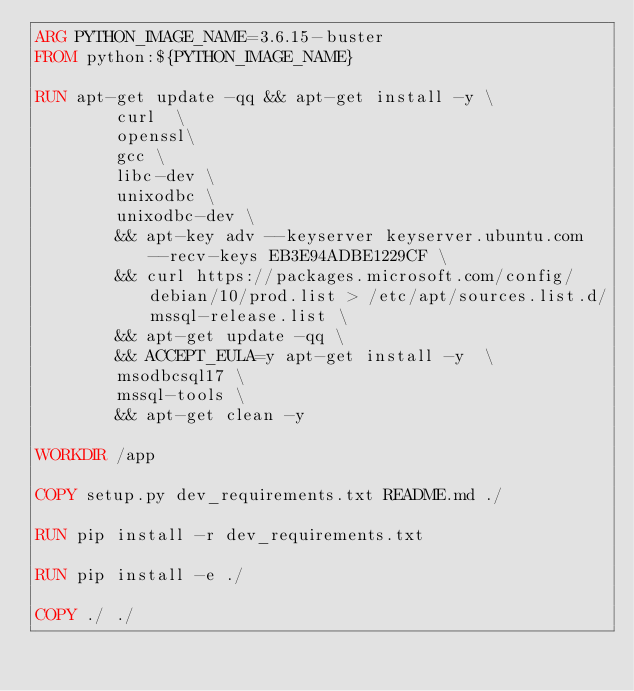<code> <loc_0><loc_0><loc_500><loc_500><_Dockerfile_>ARG PYTHON_IMAGE_NAME=3.6.15-buster
FROM python:${PYTHON_IMAGE_NAME}

RUN apt-get update -qq && apt-get install -y \
        curl  \
        openssl\
        gcc \
        libc-dev \
        unixodbc \
        unixodbc-dev \
        && apt-key adv --keyserver keyserver.ubuntu.com --recv-keys EB3E94ADBE1229CF \
        && curl https://packages.microsoft.com/config/debian/10/prod.list > /etc/apt/sources.list.d/mssql-release.list \
        && apt-get update -qq \
        && ACCEPT_EULA=y apt-get install -y  \
        msodbcsql17 \
        mssql-tools \
        && apt-get clean -y

WORKDIR /app

COPY setup.py dev_requirements.txt README.md ./

RUN pip install -r dev_requirements.txt

RUN pip install -e ./

COPY ./ ./</code> 